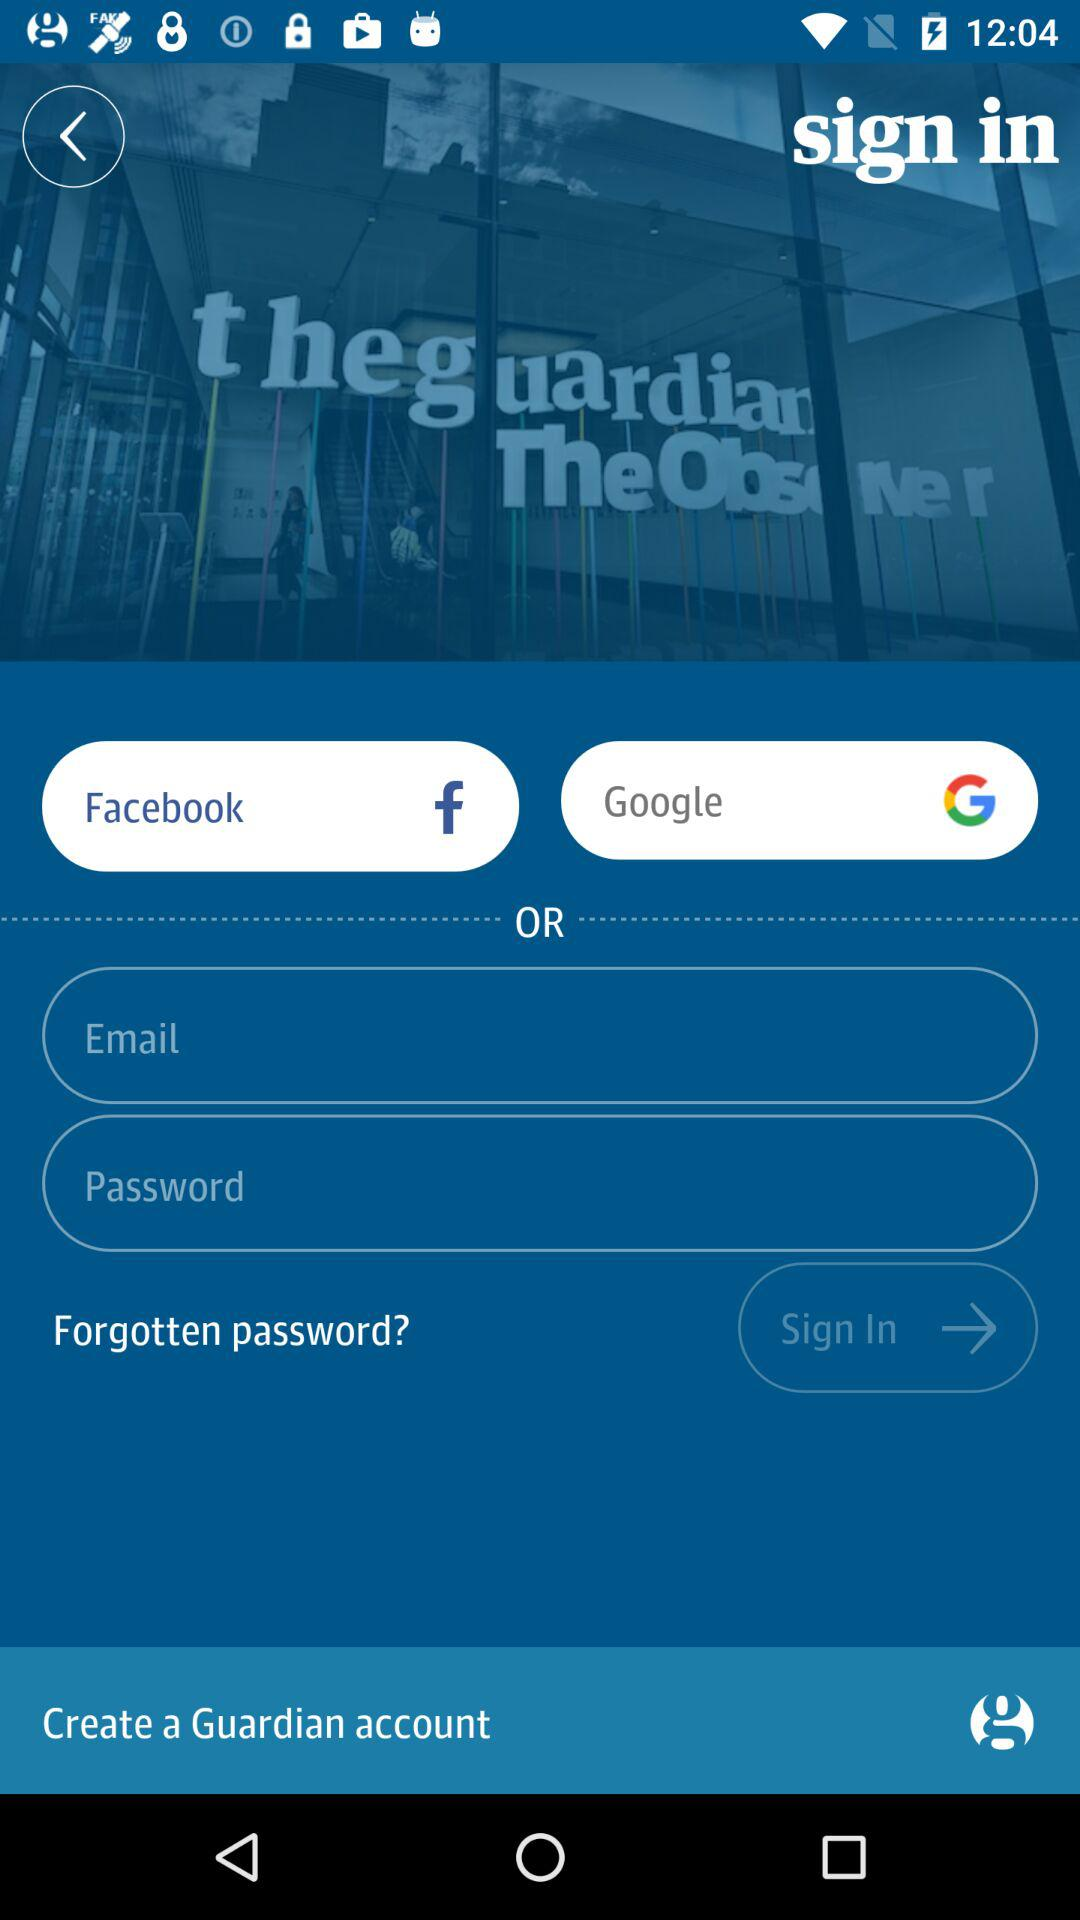Can we reset password?
When the provided information is insufficient, respond with <no answer>. <no answer> 